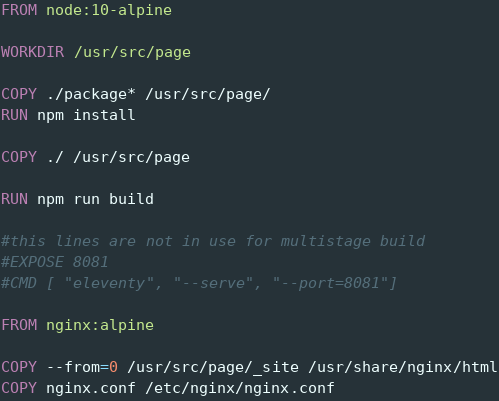<code> <loc_0><loc_0><loc_500><loc_500><_Dockerfile_>FROM node:10-alpine

WORKDIR /usr/src/page

COPY ./package* /usr/src/page/
RUN npm install

COPY ./ /usr/src/page

RUN npm run build

#this lines are not in use for multistage build
#EXPOSE 8081
#CMD [ "eleventy", "--serve", "--port=8081"]

FROM nginx:alpine

COPY --from=0 /usr/src/page/_site /usr/share/nginx/html
COPY nginx.conf /etc/nginx/nginx.conf
</code> 